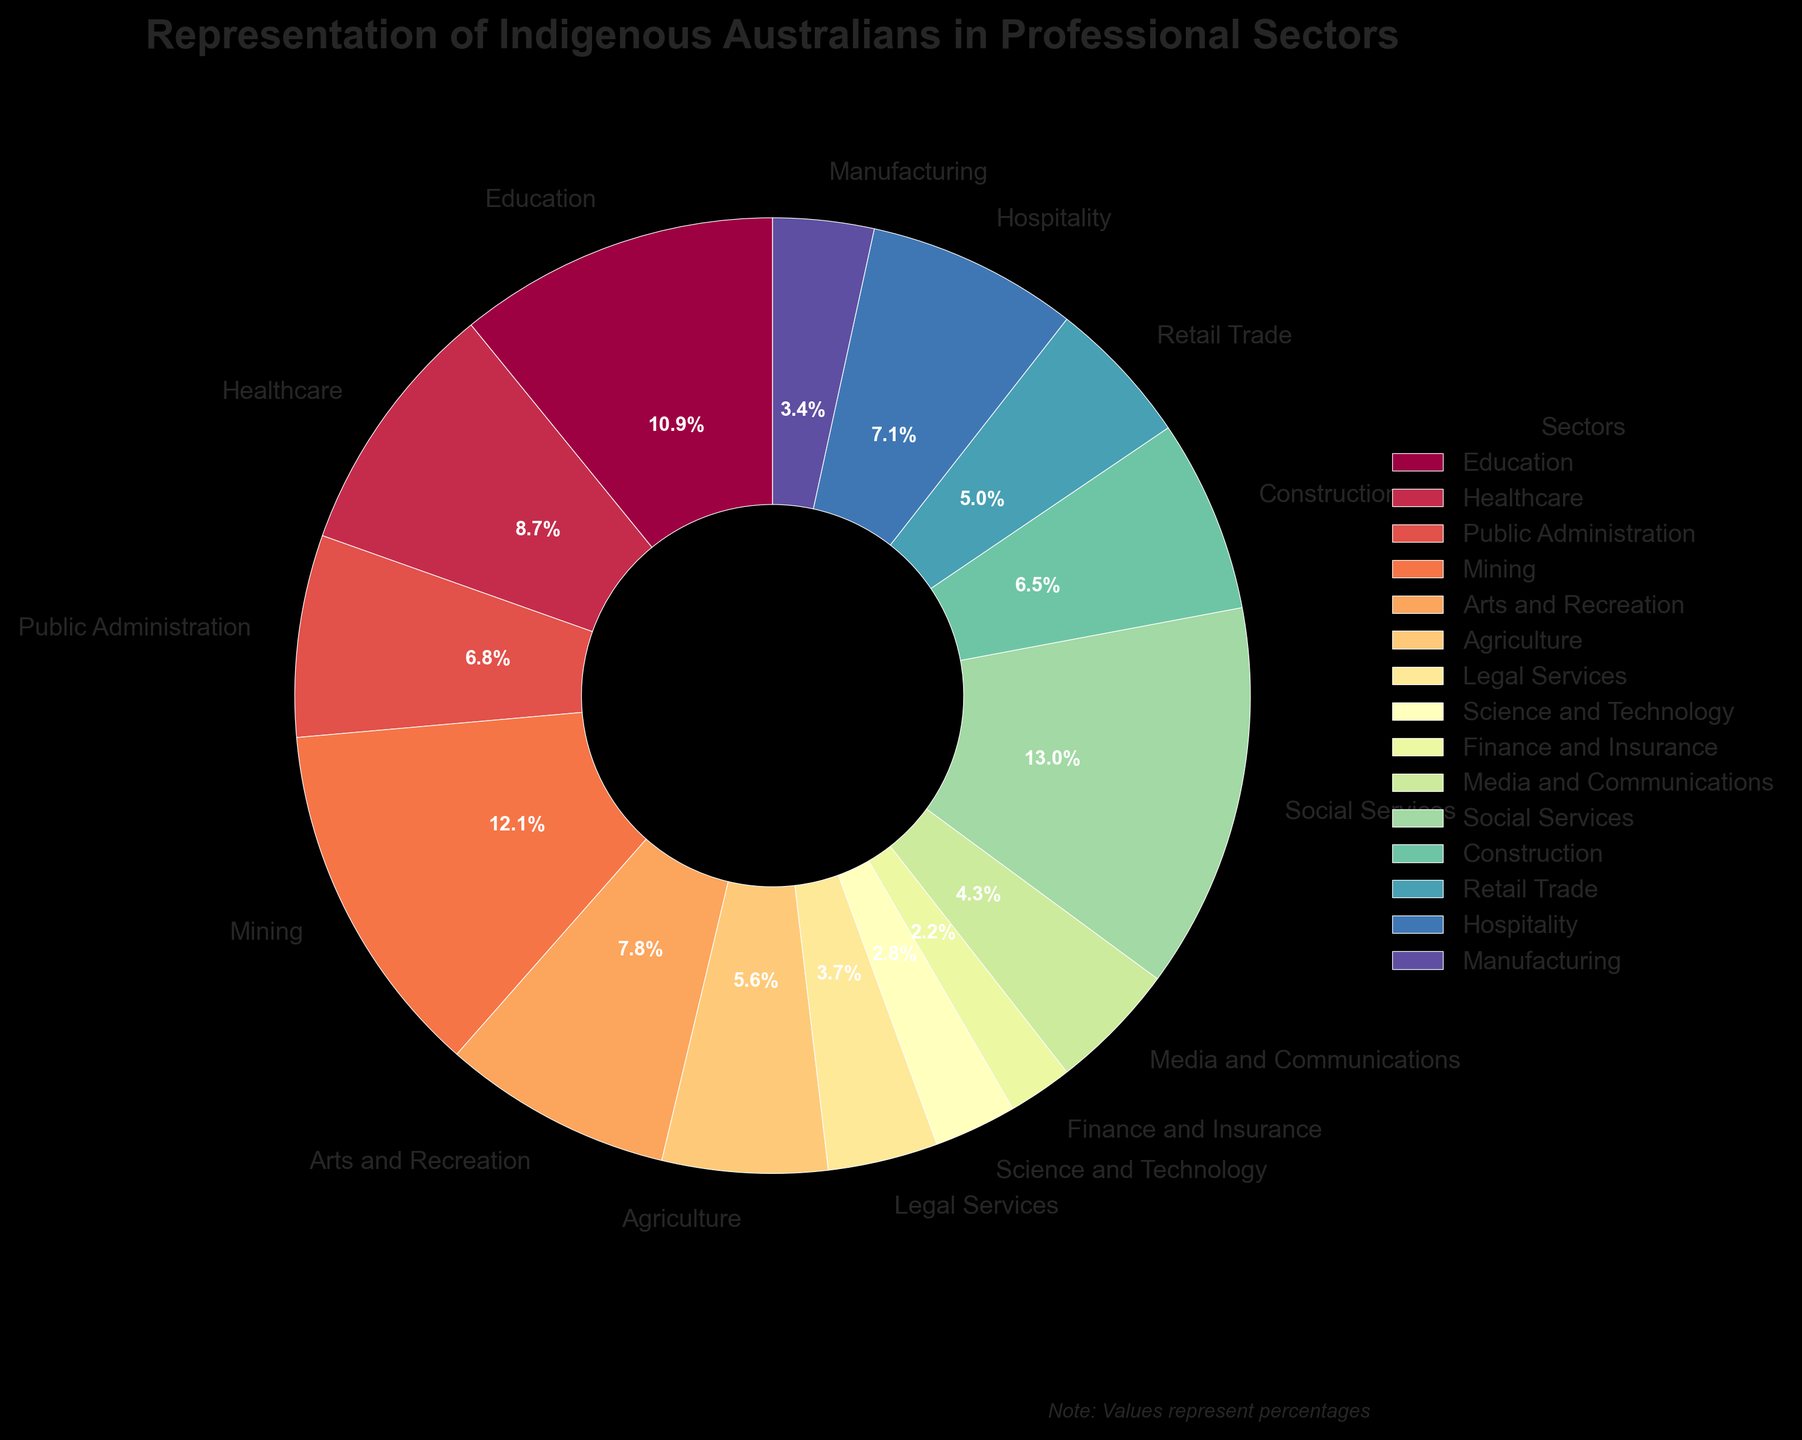What sector has the highest representation of Indigenous Australians? Look at the sector with the largest segment in the pie chart. Social Services has the largest segment at 4.2%.
Answer: Social Services Which sectors have a representation below 1%? Identify the segments in the pie chart representing less than 1%. Both Science and Technology and Finance and Insurance are below 1% at 0.9% and 0.7% respectively.
Answer: Science and Technology, Finance and Insurance What is the combined percentage representation of Indigenous Australians in Healthcare and Education? Add the percentages for Healthcare and Education. Healthcare is 2.8% and Education is 3.5%, combining to 2.8 + 3.5 = 6.3%.
Answer: 6.3% Which sector has a higher representation: Agriculture or Hospitality? Compare the segments for Agriculture and Hospitality. Agriculture is 1.8% while Hospitality is 2.3%.
Answer: Hospitality What are the three sectors with the lowest representation of Indigenous Australians? Identify the three smallest segments in the pie chart. Legal Services (1.2%), Science and Technology (0.9%), and Finance and Insurance (0.7%) are the smallest.
Answer: Legal Services, Science and Technology, Finance and Insurance How much greater is the representation in Mining compared to Manufacturing? Subtract the percentage for Manufacturing from that of Mining. Mining is 3.9% and Manufacturing is 1.1%, so the difference is 3.9 - 1.1 = 2.8%.
Answer: 2.8% What sectors have a representation between 1% and 2%? Identify the segments that fall within the range of 1% to 2%. Legal Services (1.2%), Media and Communications (1.4%), Retail Trade (1.6%), and Manufacturing (1.1%).
Answer: Legal Services, Media and Communications, Retail Trade, Manufacturing If you combined the representation of Arts and Recreation with Construction, what would be their total representation? Add the percentages of Arts and Recreation and Construction. Arts and Recreation is 2.5% and Construction is 2.1%, combining to 2.5 + 2.1 = 4.6%.
Answer: 4.6% Is the representation of Indigenous Australians higher in Public Administration or Retail Trade? Compare the segments for Public Administration and Retail Trade. Public Administration is 2.2% while Retail Trade is 1.6%.
Answer: Public Administration What percentage of sectors have a representation greater than 2.5%? Count the number of sectors with representation more than 2.5% and divide by the total number of sectors (15). Social Services (4.2%), Mining (3.9%), and Education (3.5%) satisfy this condition, so 3/15 = 20%.
Answer: 20% 